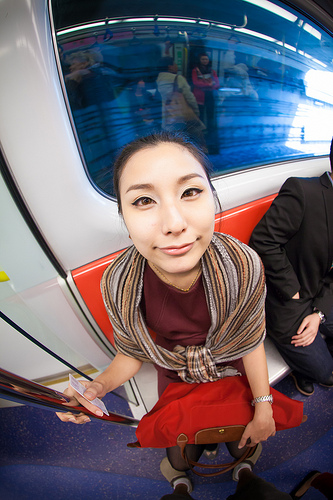<image>
Is there a women on the bag? No. The women is not positioned on the bag. They may be near each other, but the women is not supported by or resting on top of the bag. Where is the shoe in relation to the bench? Is it under the bench? No. The shoe is not positioned under the bench. The vertical relationship between these objects is different. Where is the pole in relation to the train? Is it in the train? Yes. The pole is contained within or inside the train, showing a containment relationship. 